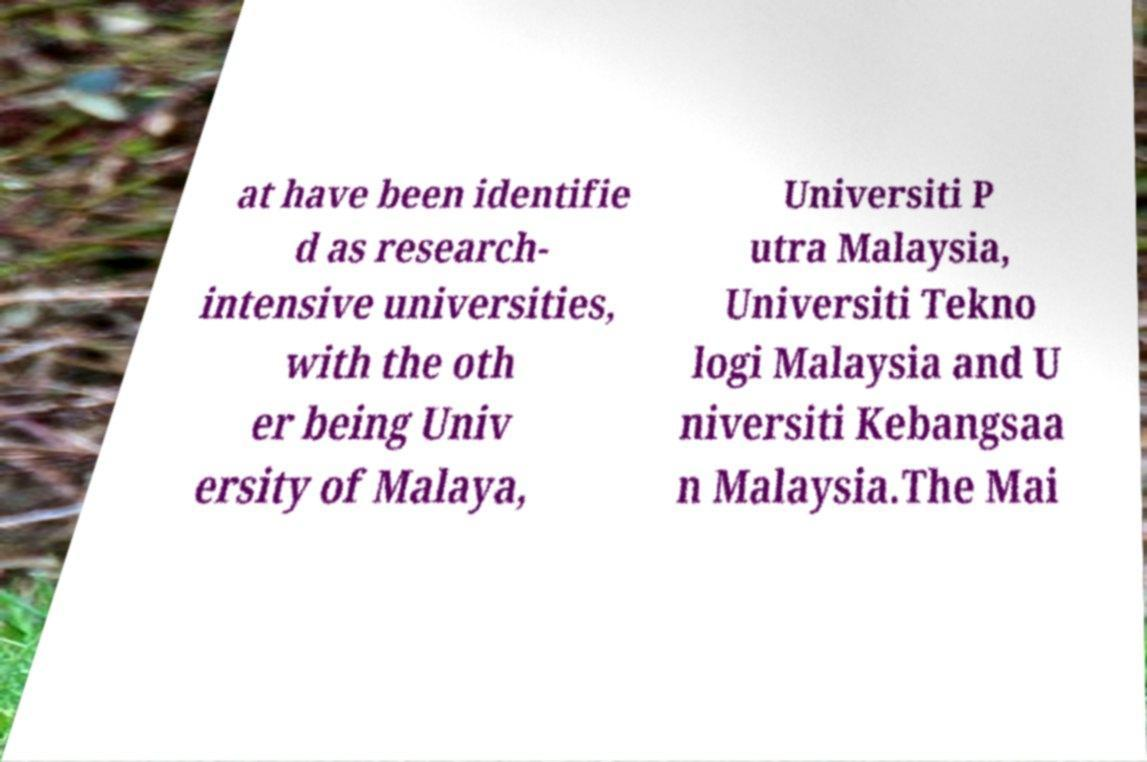Please read and relay the text visible in this image. What does it say? at have been identifie d as research- intensive universities, with the oth er being Univ ersity of Malaya, Universiti P utra Malaysia, Universiti Tekno logi Malaysia and U niversiti Kebangsaa n Malaysia.The Mai 